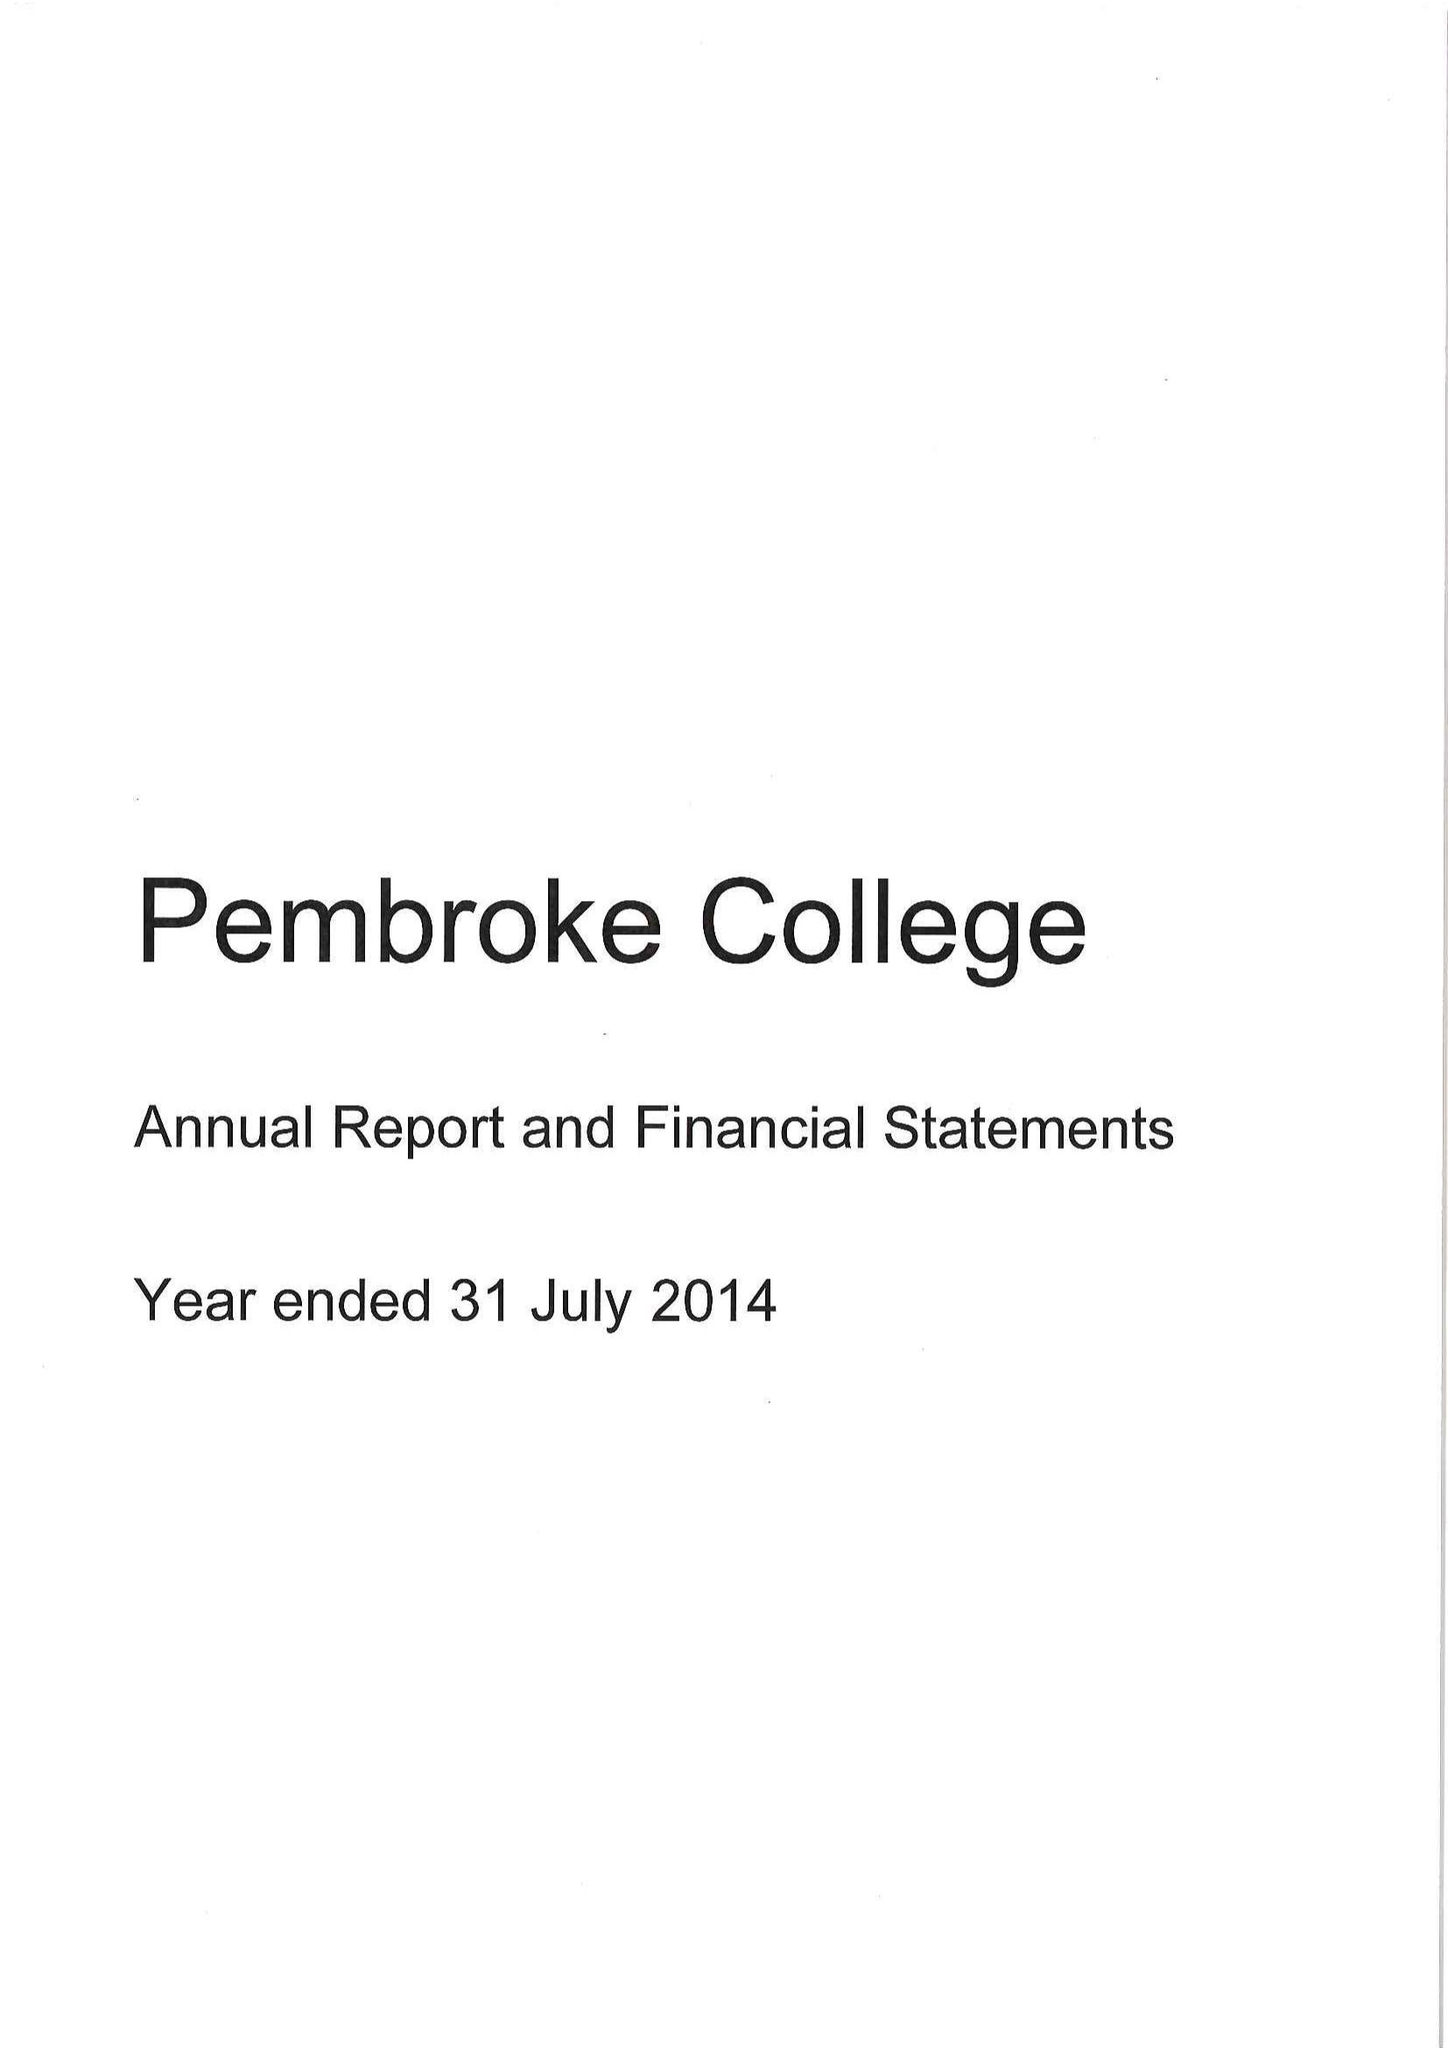What is the value for the address__postcode?
Answer the question using a single word or phrase. OX1 1DW 